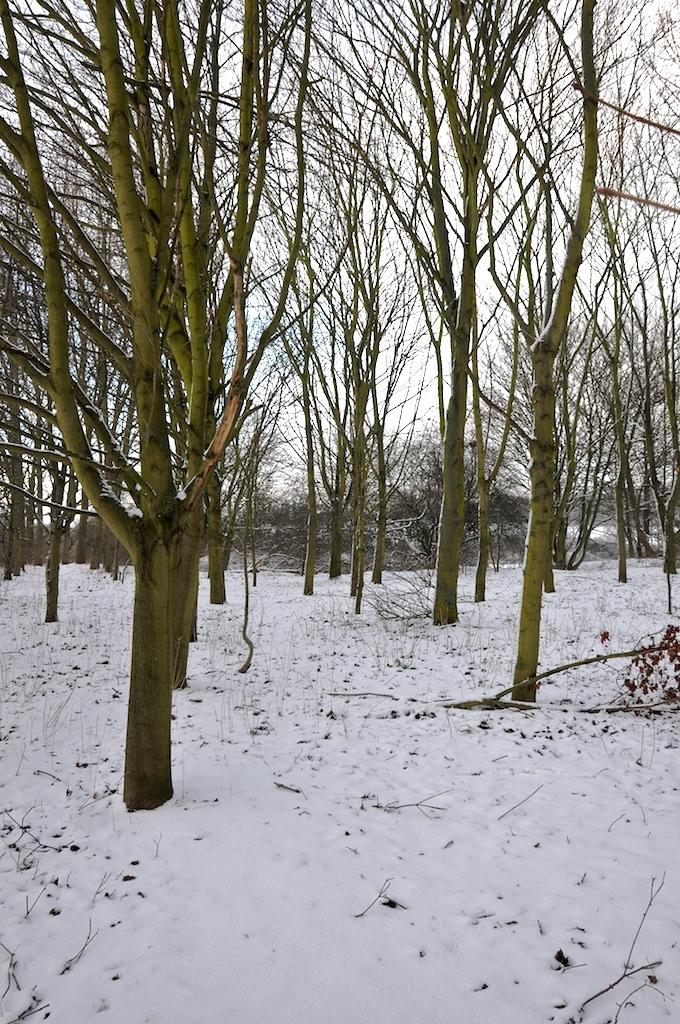What type of vegetation can be seen in the image? There are trees in the image. What is covering the ground in the image? There is snow on the ground in the image. What part of the natural environment is visible in the image? The sky is visible in the image. How much money is being exchanged between the trees in the image? There is no money being exchanged in the image; it features trees and snow on the ground. Can you describe the type of plane flying in the sky in the image? There is no plane visible in the sky in the image; it only shows trees, snow, and the sky. 